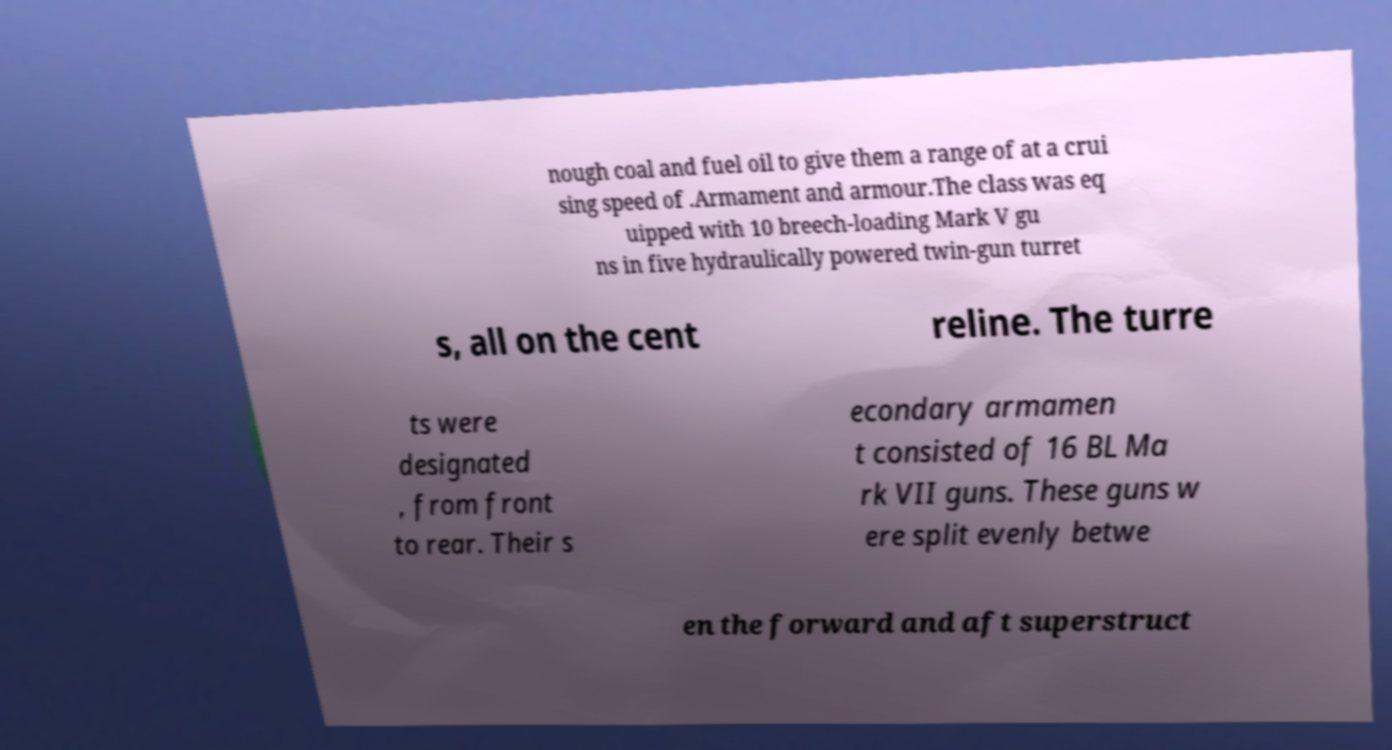Can you read and provide the text displayed in the image?This photo seems to have some interesting text. Can you extract and type it out for me? nough coal and fuel oil to give them a range of at a crui sing speed of .Armament and armour.The class was eq uipped with 10 breech-loading Mark V gu ns in five hydraulically powered twin-gun turret s, all on the cent reline. The turre ts were designated , from front to rear. Their s econdary armamen t consisted of 16 BL Ma rk VII guns. These guns w ere split evenly betwe en the forward and aft superstruct 